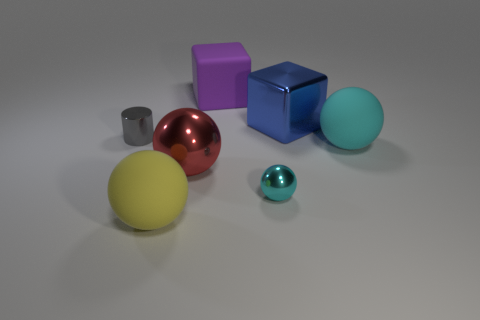There is a big object that is both behind the small cyan metallic thing and on the left side of the big purple thing; what material is it?
Keep it short and to the point. Metal. There is a large matte sphere to the left of the rubber thing to the right of the purple rubber cube; what is its color?
Your answer should be compact. Yellow. What material is the big red thing that is the same shape as the large cyan rubber object?
Provide a succinct answer. Metal. What is the color of the large rubber thing that is in front of the small object that is on the right side of the tiny metallic object that is left of the yellow thing?
Provide a succinct answer. Yellow. How many objects are large red shiny balls or large purple matte objects?
Provide a short and direct response. 2. How many big gray matte things are the same shape as the big red object?
Keep it short and to the point. 0. Are the blue object and the sphere that is to the left of the big red shiny object made of the same material?
Your response must be concise. No. What is the size of the cylinder that is made of the same material as the small sphere?
Offer a terse response. Small. There is a matte ball that is behind the red object; what is its size?
Give a very brief answer. Large. What number of blocks have the same size as the cyan rubber object?
Ensure brevity in your answer.  2. 